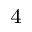<formula> <loc_0><loc_0><loc_500><loc_500>^ { 4 }</formula> 